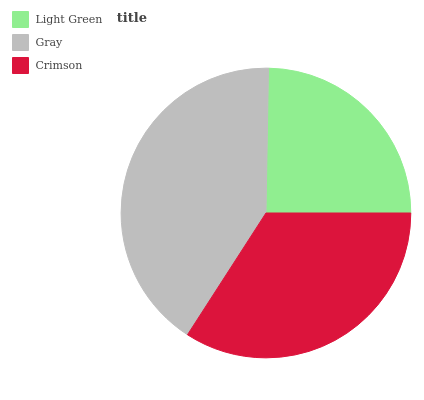Is Light Green the minimum?
Answer yes or no. Yes. Is Gray the maximum?
Answer yes or no. Yes. Is Crimson the minimum?
Answer yes or no. No. Is Crimson the maximum?
Answer yes or no. No. Is Gray greater than Crimson?
Answer yes or no. Yes. Is Crimson less than Gray?
Answer yes or no. Yes. Is Crimson greater than Gray?
Answer yes or no. No. Is Gray less than Crimson?
Answer yes or no. No. Is Crimson the high median?
Answer yes or no. Yes. Is Crimson the low median?
Answer yes or no. Yes. Is Light Green the high median?
Answer yes or no. No. Is Light Green the low median?
Answer yes or no. No. 